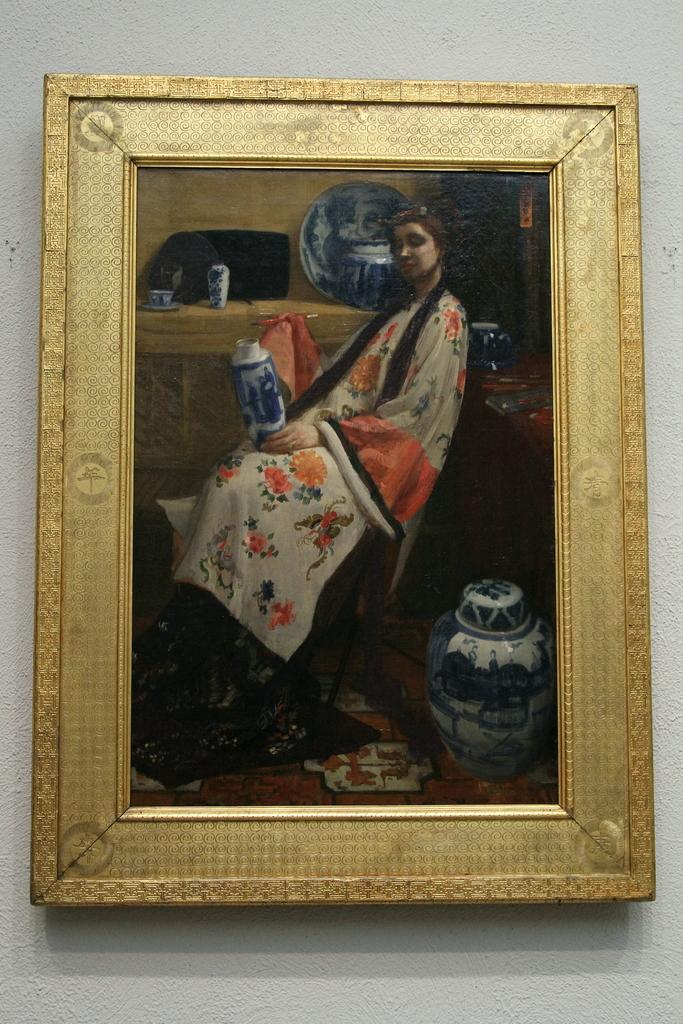What is hanging on the wall in the image? There is a frame on the wall in the image. What can be seen on the frame? There are objects visible on the frame. Can you describe the woman in the image? There is a woman in the image. How much muscle does the woman have in the image? The image does not provide information about the woman's muscle mass, so it cannot be determined. 